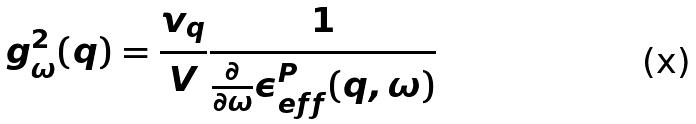<formula> <loc_0><loc_0><loc_500><loc_500>g _ { \omega } ^ { 2 } ( { q } ) = \frac { v _ { q } } { V } \frac { 1 } { \frac { \partial } { \partial \omega } \epsilon ^ { P } _ { e f f } ( { q } , \omega ) }</formula> 